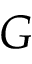<formula> <loc_0><loc_0><loc_500><loc_500>G</formula> 